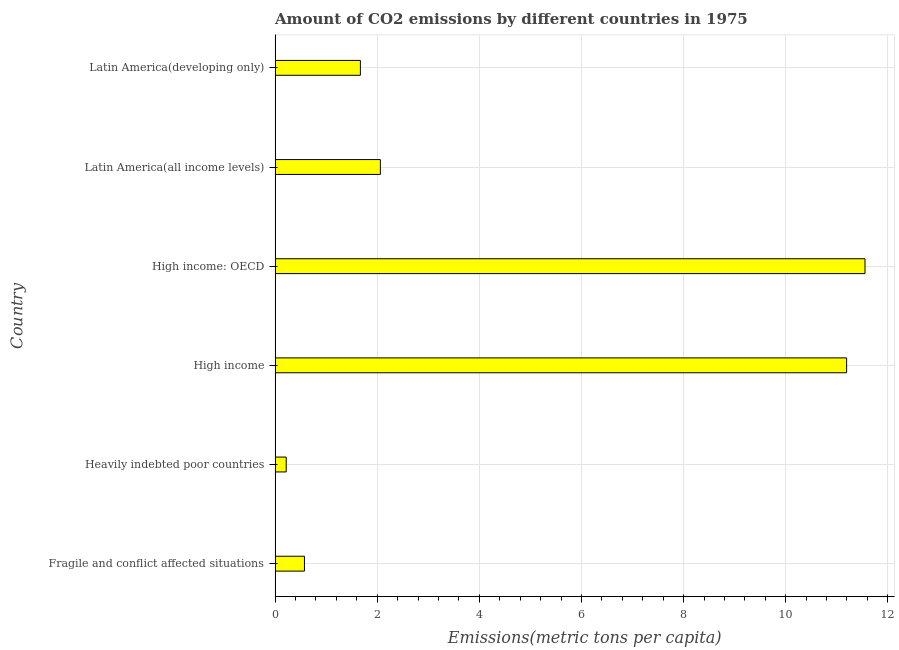Does the graph contain any zero values?
Your answer should be compact. No. Does the graph contain grids?
Make the answer very short. Yes. What is the title of the graph?
Provide a short and direct response. Amount of CO2 emissions by different countries in 1975. What is the label or title of the X-axis?
Your answer should be very brief. Emissions(metric tons per capita). What is the amount of co2 emissions in Latin America(developing only)?
Offer a terse response. 1.67. Across all countries, what is the maximum amount of co2 emissions?
Offer a terse response. 11.55. Across all countries, what is the minimum amount of co2 emissions?
Your response must be concise. 0.22. In which country was the amount of co2 emissions maximum?
Keep it short and to the point. High income: OECD. In which country was the amount of co2 emissions minimum?
Make the answer very short. Heavily indebted poor countries. What is the sum of the amount of co2 emissions?
Offer a very short reply. 27.27. What is the difference between the amount of co2 emissions in Heavily indebted poor countries and High income?
Provide a succinct answer. -10.97. What is the average amount of co2 emissions per country?
Make the answer very short. 4.54. What is the median amount of co2 emissions?
Your response must be concise. 1.87. In how many countries, is the amount of co2 emissions greater than 1.6 metric tons per capita?
Offer a terse response. 4. What is the ratio of the amount of co2 emissions in High income to that in High income: OECD?
Offer a very short reply. 0.97. Is the amount of co2 emissions in Fragile and conflict affected situations less than that in Heavily indebted poor countries?
Keep it short and to the point. No. Is the difference between the amount of co2 emissions in Fragile and conflict affected situations and Latin America(developing only) greater than the difference between any two countries?
Make the answer very short. No. What is the difference between the highest and the second highest amount of co2 emissions?
Make the answer very short. 0.36. Is the sum of the amount of co2 emissions in High income: OECD and Latin America(developing only) greater than the maximum amount of co2 emissions across all countries?
Your answer should be very brief. Yes. What is the difference between the highest and the lowest amount of co2 emissions?
Keep it short and to the point. 11.33. How many bars are there?
Ensure brevity in your answer.  6. Are all the bars in the graph horizontal?
Provide a succinct answer. Yes. How many countries are there in the graph?
Your answer should be compact. 6. What is the difference between two consecutive major ticks on the X-axis?
Your answer should be very brief. 2. Are the values on the major ticks of X-axis written in scientific E-notation?
Your answer should be compact. No. What is the Emissions(metric tons per capita) of Fragile and conflict affected situations?
Keep it short and to the point. 0.58. What is the Emissions(metric tons per capita) of Heavily indebted poor countries?
Your response must be concise. 0.22. What is the Emissions(metric tons per capita) of High income?
Ensure brevity in your answer.  11.19. What is the Emissions(metric tons per capita) in High income: OECD?
Provide a succinct answer. 11.55. What is the Emissions(metric tons per capita) of Latin America(all income levels)?
Offer a terse response. 2.06. What is the Emissions(metric tons per capita) in Latin America(developing only)?
Give a very brief answer. 1.67. What is the difference between the Emissions(metric tons per capita) in Fragile and conflict affected situations and Heavily indebted poor countries?
Provide a short and direct response. 0.36. What is the difference between the Emissions(metric tons per capita) in Fragile and conflict affected situations and High income?
Your response must be concise. -10.62. What is the difference between the Emissions(metric tons per capita) in Fragile and conflict affected situations and High income: OECD?
Your answer should be very brief. -10.98. What is the difference between the Emissions(metric tons per capita) in Fragile and conflict affected situations and Latin America(all income levels)?
Give a very brief answer. -1.49. What is the difference between the Emissions(metric tons per capita) in Fragile and conflict affected situations and Latin America(developing only)?
Your response must be concise. -1.1. What is the difference between the Emissions(metric tons per capita) in Heavily indebted poor countries and High income?
Ensure brevity in your answer.  -10.97. What is the difference between the Emissions(metric tons per capita) in Heavily indebted poor countries and High income: OECD?
Your answer should be very brief. -11.33. What is the difference between the Emissions(metric tons per capita) in Heavily indebted poor countries and Latin America(all income levels)?
Your response must be concise. -1.84. What is the difference between the Emissions(metric tons per capita) in Heavily indebted poor countries and Latin America(developing only)?
Provide a short and direct response. -1.45. What is the difference between the Emissions(metric tons per capita) in High income and High income: OECD?
Your answer should be compact. -0.36. What is the difference between the Emissions(metric tons per capita) in High income and Latin America(all income levels)?
Provide a short and direct response. 9.13. What is the difference between the Emissions(metric tons per capita) in High income and Latin America(developing only)?
Provide a succinct answer. 9.52. What is the difference between the Emissions(metric tons per capita) in High income: OECD and Latin America(all income levels)?
Make the answer very short. 9.49. What is the difference between the Emissions(metric tons per capita) in High income: OECD and Latin America(developing only)?
Provide a succinct answer. 9.88. What is the difference between the Emissions(metric tons per capita) in Latin America(all income levels) and Latin America(developing only)?
Provide a short and direct response. 0.39. What is the ratio of the Emissions(metric tons per capita) in Fragile and conflict affected situations to that in Heavily indebted poor countries?
Make the answer very short. 2.64. What is the ratio of the Emissions(metric tons per capita) in Fragile and conflict affected situations to that in High income?
Offer a very short reply. 0.05. What is the ratio of the Emissions(metric tons per capita) in Fragile and conflict affected situations to that in High income: OECD?
Provide a succinct answer. 0.05. What is the ratio of the Emissions(metric tons per capita) in Fragile and conflict affected situations to that in Latin America(all income levels)?
Give a very brief answer. 0.28. What is the ratio of the Emissions(metric tons per capita) in Fragile and conflict affected situations to that in Latin America(developing only)?
Keep it short and to the point. 0.34. What is the ratio of the Emissions(metric tons per capita) in Heavily indebted poor countries to that in High income?
Your answer should be very brief. 0.02. What is the ratio of the Emissions(metric tons per capita) in Heavily indebted poor countries to that in High income: OECD?
Keep it short and to the point. 0.02. What is the ratio of the Emissions(metric tons per capita) in Heavily indebted poor countries to that in Latin America(all income levels)?
Provide a succinct answer. 0.11. What is the ratio of the Emissions(metric tons per capita) in Heavily indebted poor countries to that in Latin America(developing only)?
Provide a succinct answer. 0.13. What is the ratio of the Emissions(metric tons per capita) in High income to that in High income: OECD?
Provide a succinct answer. 0.97. What is the ratio of the Emissions(metric tons per capita) in High income to that in Latin America(all income levels)?
Provide a succinct answer. 5.43. What is the ratio of the Emissions(metric tons per capita) in High income to that in Latin America(developing only)?
Make the answer very short. 6.7. What is the ratio of the Emissions(metric tons per capita) in High income: OECD to that in Latin America(all income levels)?
Your response must be concise. 5.6. What is the ratio of the Emissions(metric tons per capita) in High income: OECD to that in Latin America(developing only)?
Your answer should be compact. 6.92. What is the ratio of the Emissions(metric tons per capita) in Latin America(all income levels) to that in Latin America(developing only)?
Make the answer very short. 1.23. 